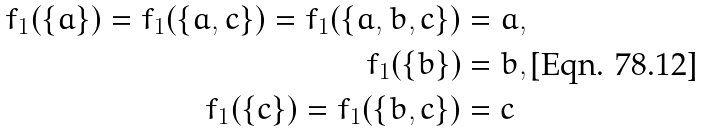Convert formula to latex. <formula><loc_0><loc_0><loc_500><loc_500>f _ { 1 } ( \{ a \} ) = f _ { 1 } ( \{ a , c \} ) = f _ { 1 } ( \{ a , b , c \} ) & = a , \\ f _ { 1 } ( \{ b \} ) & = b , \\ f _ { 1 } ( \{ c \} ) = f _ { 1 } ( \{ b , c \} ) & = c</formula> 